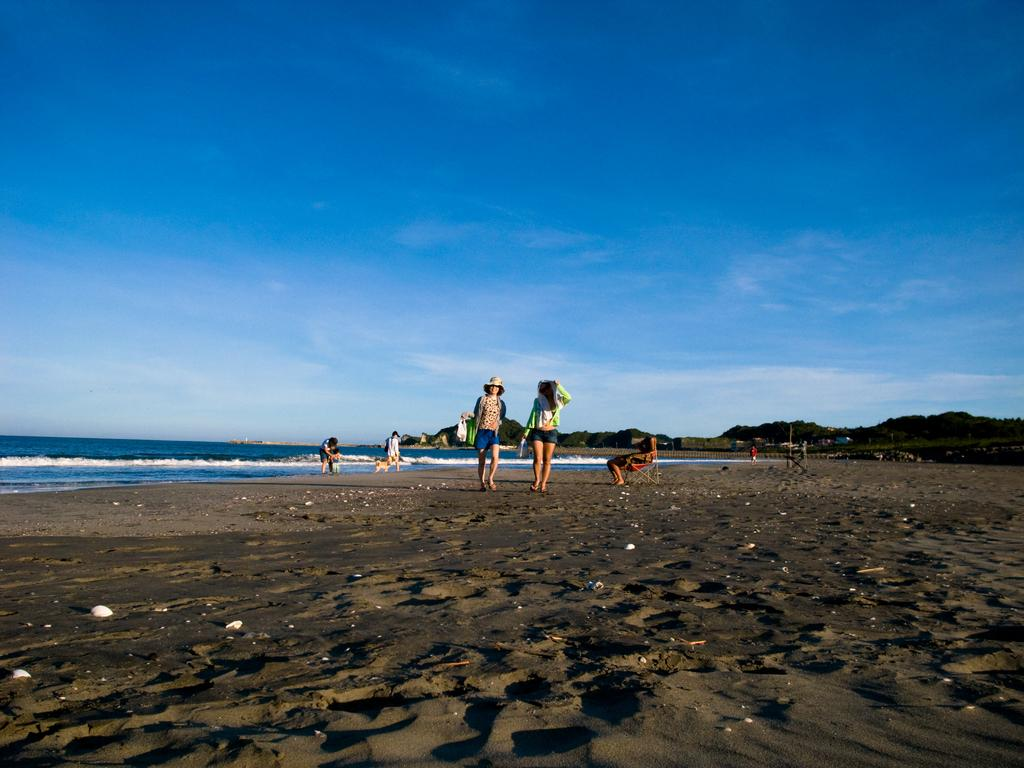Who is present in the image? There are people in the image. Where are the people located? The people are at a beach. What can be seen in the background of the image? There is an ocean and clouds in the sky in the background of the image. How much powder is being used by the people in the image? There is no mention of powder in the image, so it cannot be determined how much is being used. 